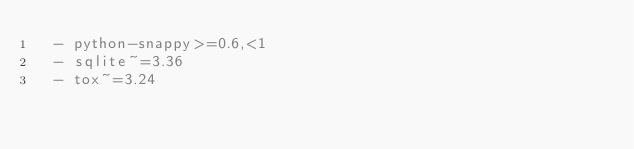<code> <loc_0><loc_0><loc_500><loc_500><_YAML_>  - python-snappy>=0.6,<1
  - sqlite~=3.36
  - tox~=3.24
</code> 